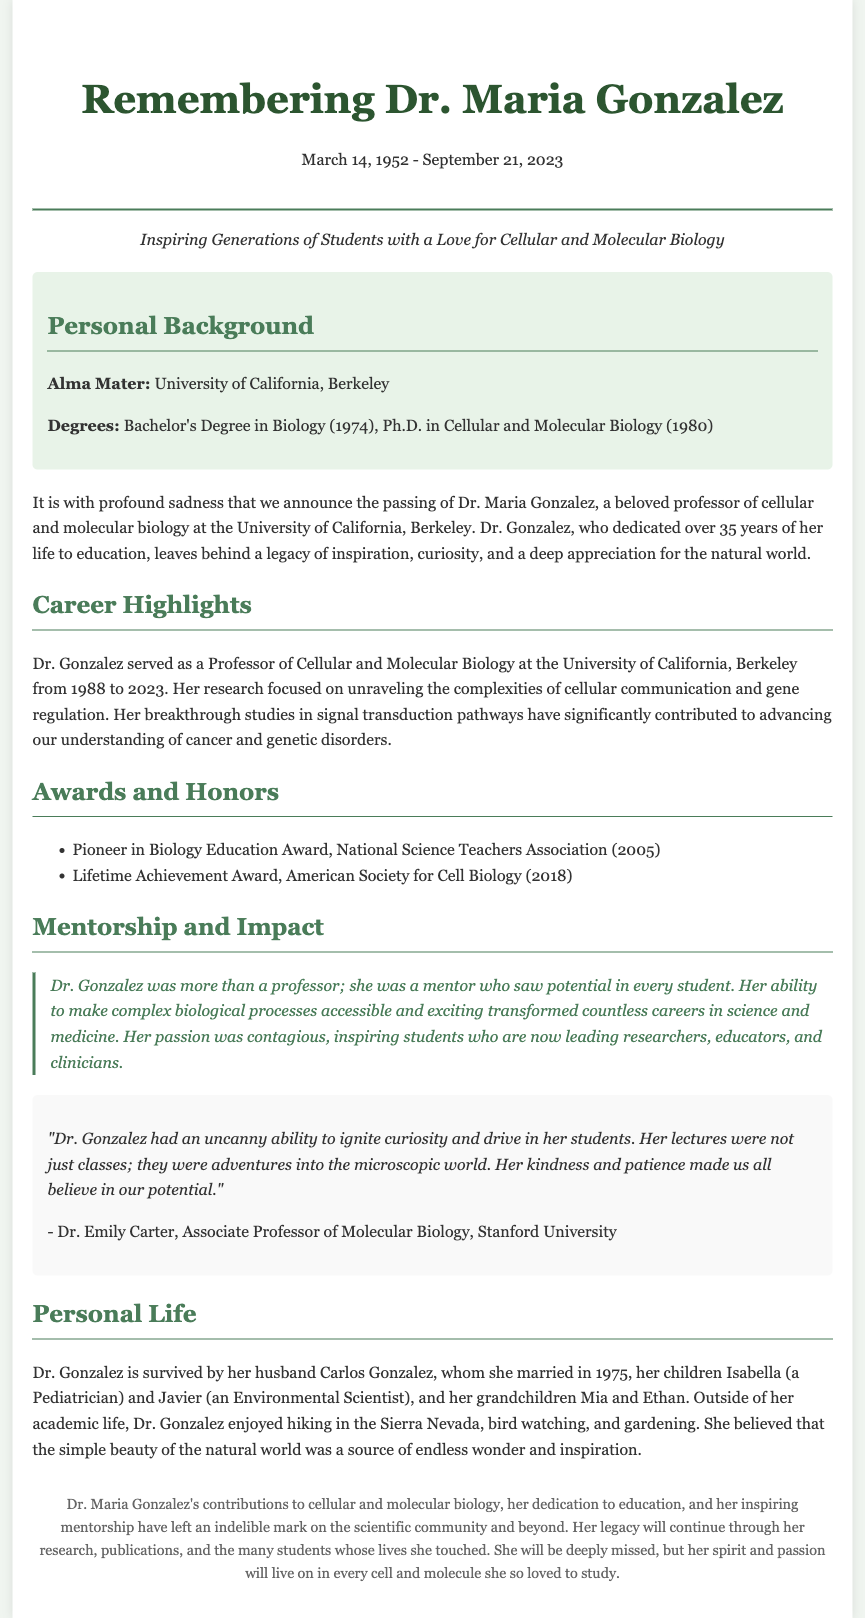What was Dr. Maria Gonzalez's alma mater? The document states that Dr. Gonzalez attended the University of California, Berkeley.
Answer: University of California, Berkeley What degrees did Dr. Gonzalez obtain? The document specifies that she earned a Bachelor's Degree in Biology and a Ph.D. in Cellular and Molecular Biology.
Answer: Bachelor's Degree in Biology, Ph.D. in Cellular and Molecular Biology In what year did Dr. Gonzalez begin her teaching career at UC Berkeley? According to the document, she served as a professor from 1988 until her passing in 2023, indicating her career began in 1988.
Answer: 1988 What notable award did Dr. Gonzalez receive in 2005? The document mentions that she received the Pioneer in Biology Education Award from the National Science Teachers Association.
Answer: Pioneer in Biology Education Award How did Dr. Gonzalez impact her students according to the testimonial? The testimonial suggests she ignited curiosity and drive in her students, transforming their careers with her engaging teaching methods.
Answer: Ignited curiosity and drive What hobbies did Dr. Gonzalez enjoy outside of her academic life? The document lists hiking in the Sierra Nevada, bird watching, and gardening as her hobbies.
Answer: Hiking, bird watching, gardening How long did Dr. Gonzalez dedicate to education? The document states that she dedicated over 35 years to education.
Answer: Over 35 years Who is Dr. Gonzalez's spouse? The document indicates that she is survived by her husband, Carlos Gonzalez.
Answer: Carlos Gonzalez 